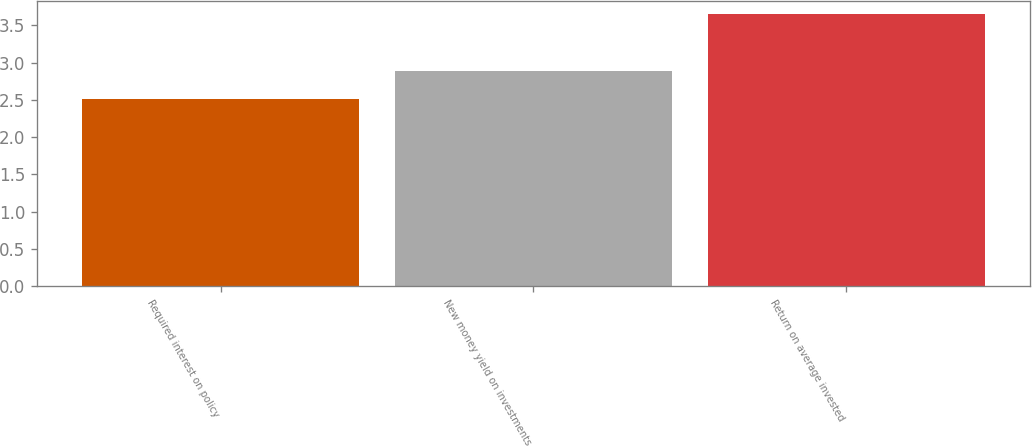Convert chart. <chart><loc_0><loc_0><loc_500><loc_500><bar_chart><fcel>Required interest on policy<fcel>New money yield on investments<fcel>Return on average invested<nl><fcel>2.51<fcel>2.88<fcel>3.65<nl></chart> 